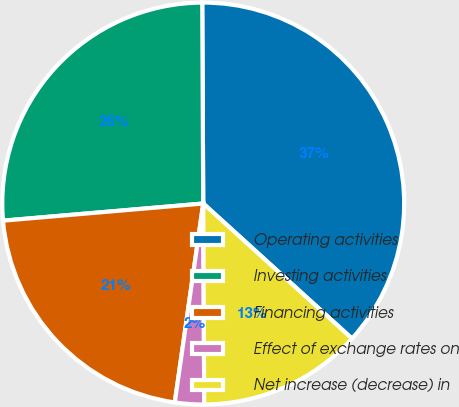Convert chart. <chart><loc_0><loc_0><loc_500><loc_500><pie_chart><fcel>Operating activities<fcel>Investing activities<fcel>Financing activities<fcel>Effect of exchange rates on<fcel>Net increase (decrease) in<nl><fcel>36.81%<fcel>26.28%<fcel>21.38%<fcel>2.34%<fcel>13.19%<nl></chart> 